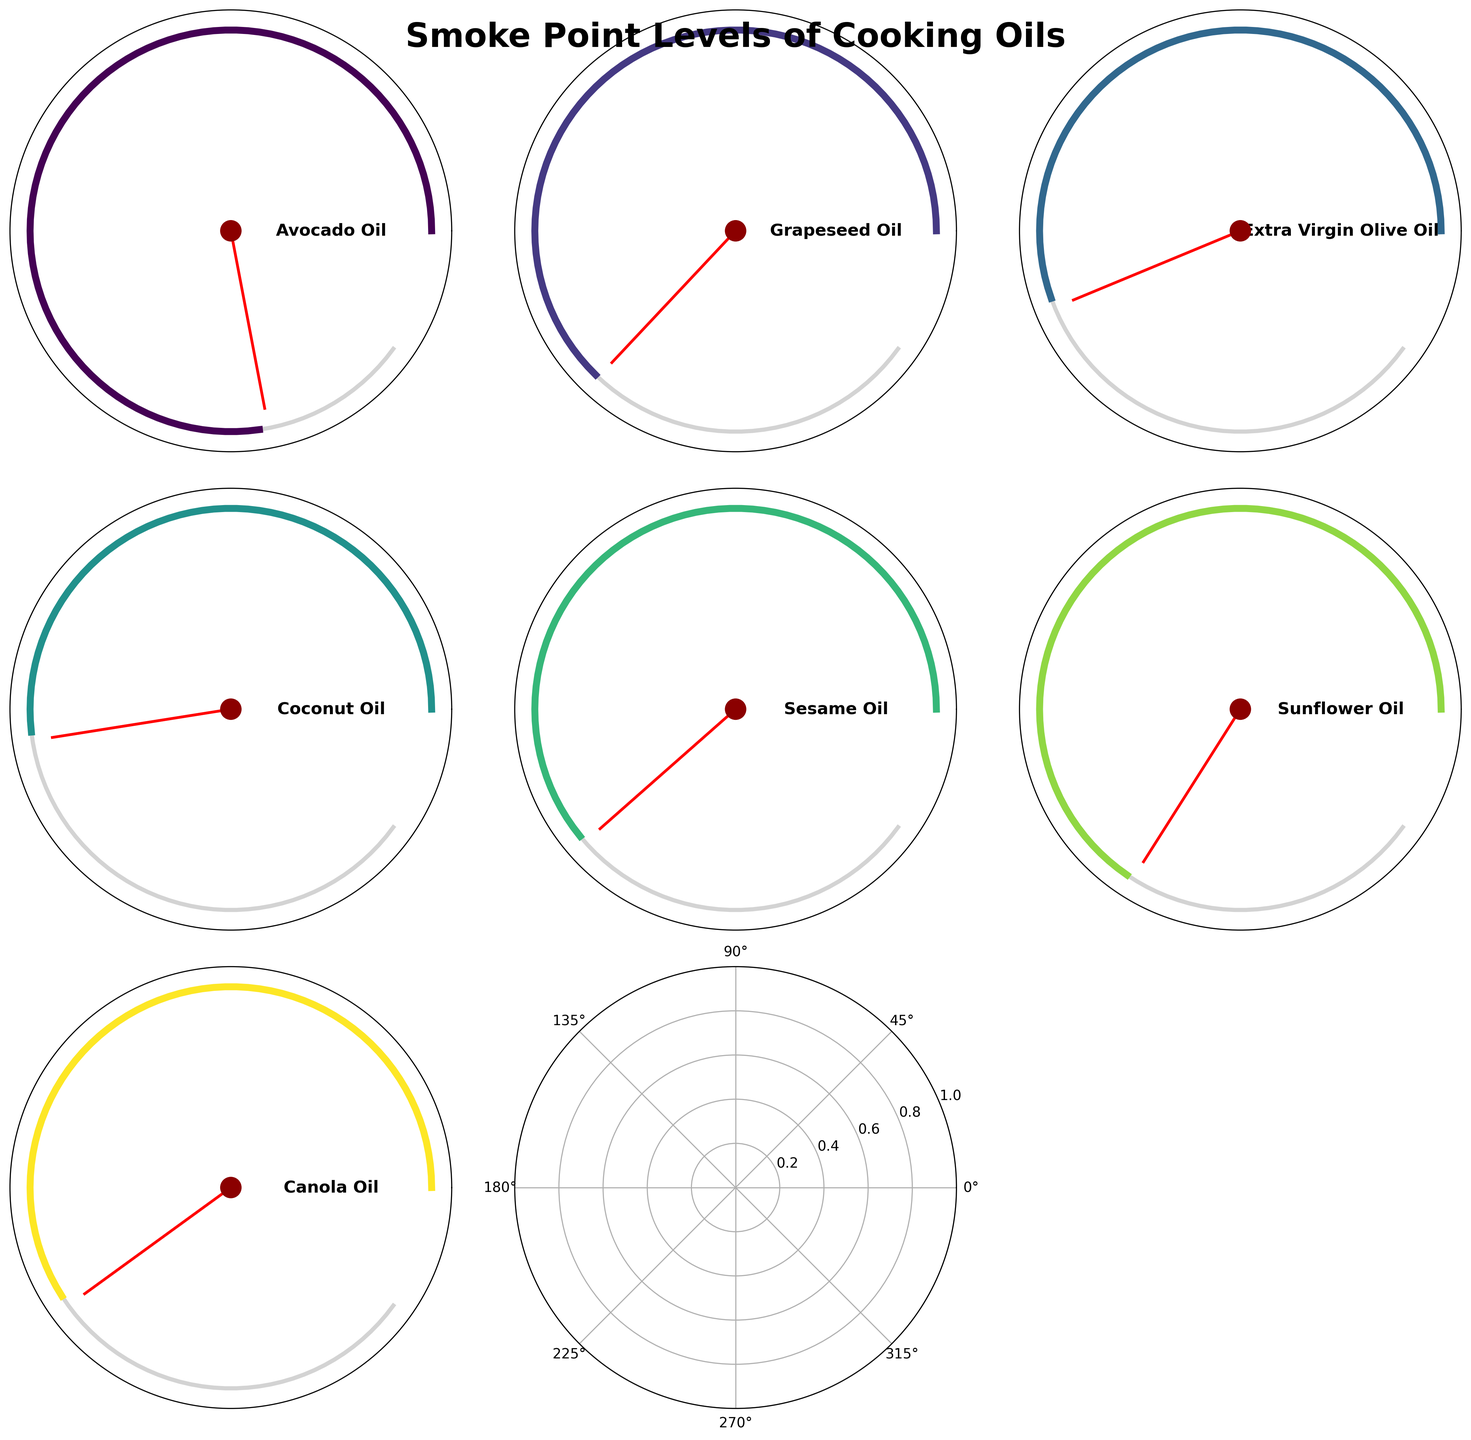What is the smoke point of Avocado Oil? The gauge chart for Avocado Oil shows that the needle points to 520°F.
Answer: 520°F Which oil has the lowest smoke point? By comparing the needle positions on each gauge chart, Extra Virgin Olive Oil has the lowest smoke point at 375°F.
Answer: Extra Virgin Olive Oil How many oils have a smoke point above 400°F? Observing the gauge charts, Avocado Oil, Grapeseed Oil, Sunflower Oil, and Canola Oil all have smoke points above 400°F. This totals to four oils.
Answer: 4 What is the difference in smoke points between Sunflower Oil and Coconut Oil? Sunflower Oil has a smoke point of 440°F, and Coconut Oil has a smoke point of 350°F. The difference is 440°F - 350°F = 90°F.
Answer: 90°F Which oils have a smoke point within the range of 380°F to 420°F? From the gauge charts, the oils that fall within this range are Grapeseed Oil with a smoke point of 420°F and Sesame Oil with a smoke point of 410°F.
Answer: Grapeseed Oil, Sesame Oil What cooking oil has a smoke point of 400°F? The gauge chart for Canola Oil shows that the needle points to 400°F.
Answer: Canola Oil Which oil's smoke point is closest to 375°F? Extra Virgin Olive Oil has a smoke point of 375°F, which exactly matches the value.
Answer: Extra Virgin Olive Oil What is the median smoke point value of all the oils? Ordering the smoke points: 350°F (Coconut Oil), 375°F (Extra Virgin Olive Oil), 400°F (Canola Oil), 410°F (Sesame Oil), 420°F (Grapeseed Oil), 440°F (Sunflower Oil), 520°F (Avocado Oil). The median is the middle value, which is 410°F.
Answer: 410°F Arrange the oils in descending order of their smoke points. The oils arranged from highest to lowest smoke points are: Avocado Oil (520°F), Sunflower Oil (440°F), Grapeseed Oil (420°F), Sesame Oil (410°F), Canola Oil (400°F), Extra Virgin Olive Oil (375°F), Coconut Oil (350°F).
Answer: Avocado Oil, Sunflower Oil, Grapeseed Oil, Sesame Oil, Canola Oil, Extra Virgin Olive Oil, Coconut Oil 